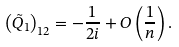Convert formula to latex. <formula><loc_0><loc_0><loc_500><loc_500>\left ( \tilde { Q } _ { 1 } \right ) _ { 1 2 } = - \frac { 1 } { 2 i } + O \left ( \frac { 1 } { n } \right ) .</formula> 